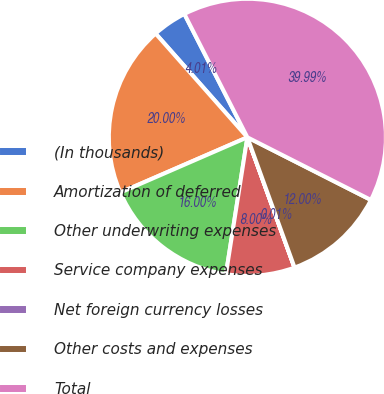Convert chart. <chart><loc_0><loc_0><loc_500><loc_500><pie_chart><fcel>(In thousands)<fcel>Amortization of deferred<fcel>Other underwriting expenses<fcel>Service company expenses<fcel>Net foreign currency losses<fcel>Other costs and expenses<fcel>Total<nl><fcel>4.01%<fcel>20.0%<fcel>16.0%<fcel>8.0%<fcel>0.01%<fcel>12.0%<fcel>39.99%<nl></chart> 